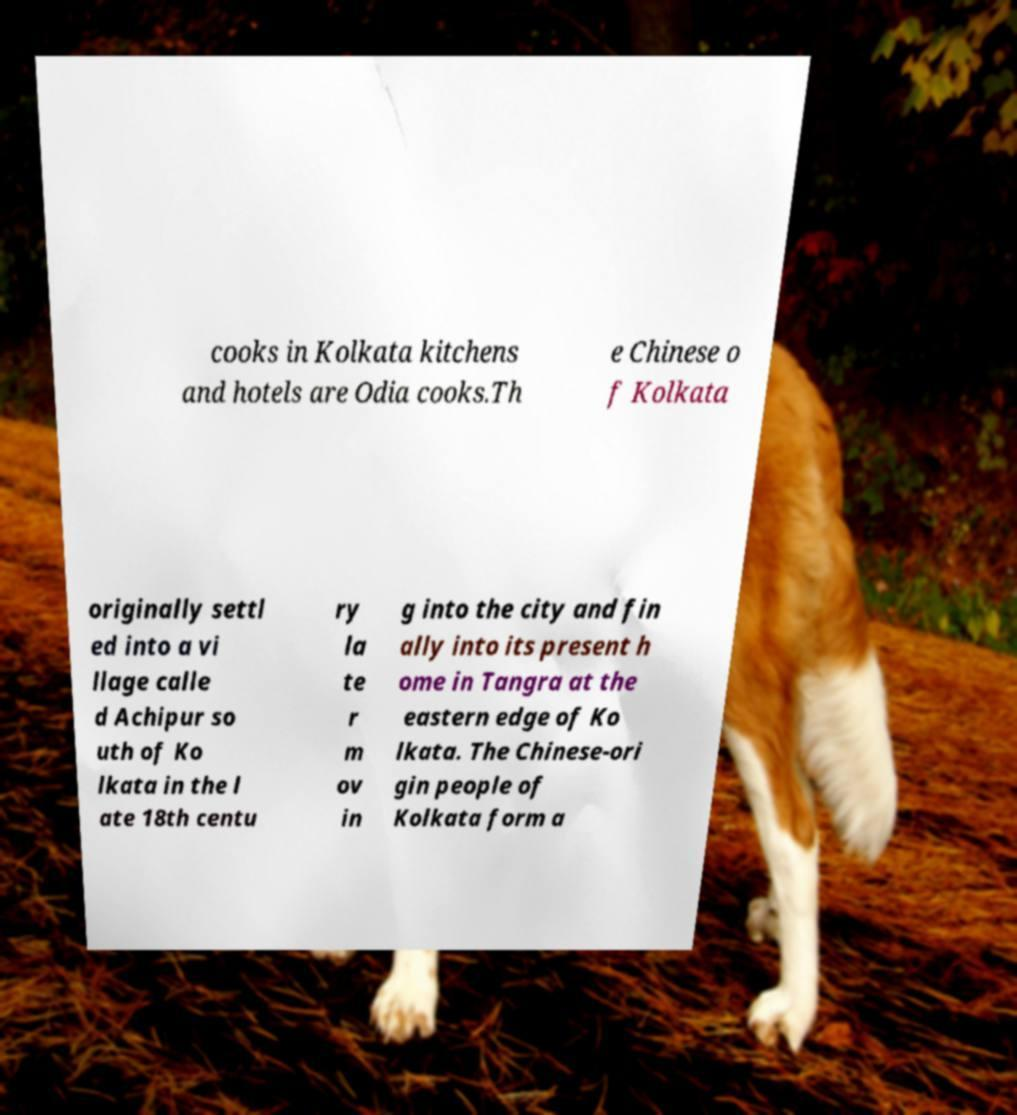I need the written content from this picture converted into text. Can you do that? cooks in Kolkata kitchens and hotels are Odia cooks.Th e Chinese o f Kolkata originally settl ed into a vi llage calle d Achipur so uth of Ko lkata in the l ate 18th centu ry la te r m ov in g into the city and fin ally into its present h ome in Tangra at the eastern edge of Ko lkata. The Chinese-ori gin people of Kolkata form a 